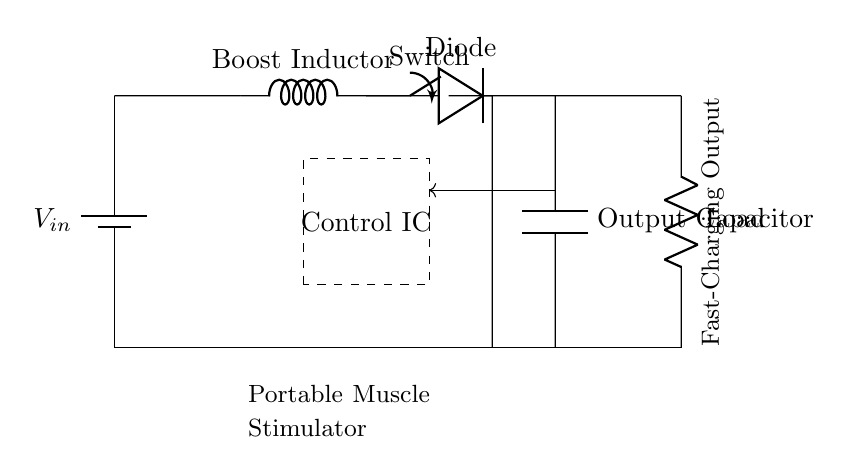What is the function of the Boost Inductor? The Boost Inductor in this circuit is used to elevate the input voltage, allowing the circuit to supply a higher output voltage than provided by the battery. This is typical for fast-charging applications where higher voltage is needed to charge the load quickly.
Answer: Elevate voltage What component is used for controlling the operation of the circuit? The component indicated by the dashed rectangle is the Control IC. This Integrated Circuit regulates the charging operation and switching of the boost converter to maintain the desired output voltage.
Answer: Control IC What type of load does this circuit support? The circuit diagram indicates an "Output Load" labeled as Load, which suggests that it's designed to support a portable muscle stimulator, specifically for muscle recovery. This implies that the load is likely a device requiring intermittent power for electric stimulation.
Answer: Portable muscle stimulator How many diodes are present in the circuit? The circuit diagram shows one diode connected in series with the output path. This diode allows current to flow in one direction, preventing backflow which is essential in charging circuits to ensure the output capacitor only receives charge.
Answer: One What is the purpose of the output capacitor? The Output Capacitor smooths out the voltage supply to the load by storing charge. Its role is particularly crucial in fast-charging applications to ensure a stable voltage level while the load draws current, preventing voltage drops during operation.
Answer: Smooth voltage supply What does the feedback from the output to the Control IC accomplish? The feedback loop enables the Control IC to monitor the output voltage. By receiving this feedback, the IC can make adjustments to the switching of the boost converter, ensuring that the output voltage remains consistent with the desired parameters.
Answer: Maintain output voltage consistency What type of switch is shown in the diagram? The switch depicted in the circuit is a standard switch. In a charging circuit, this switch would typically control the connection between the battery and the boost converter, enabling or disabling the charging process based on circuit conditions or user input.
Answer: Standard switch 